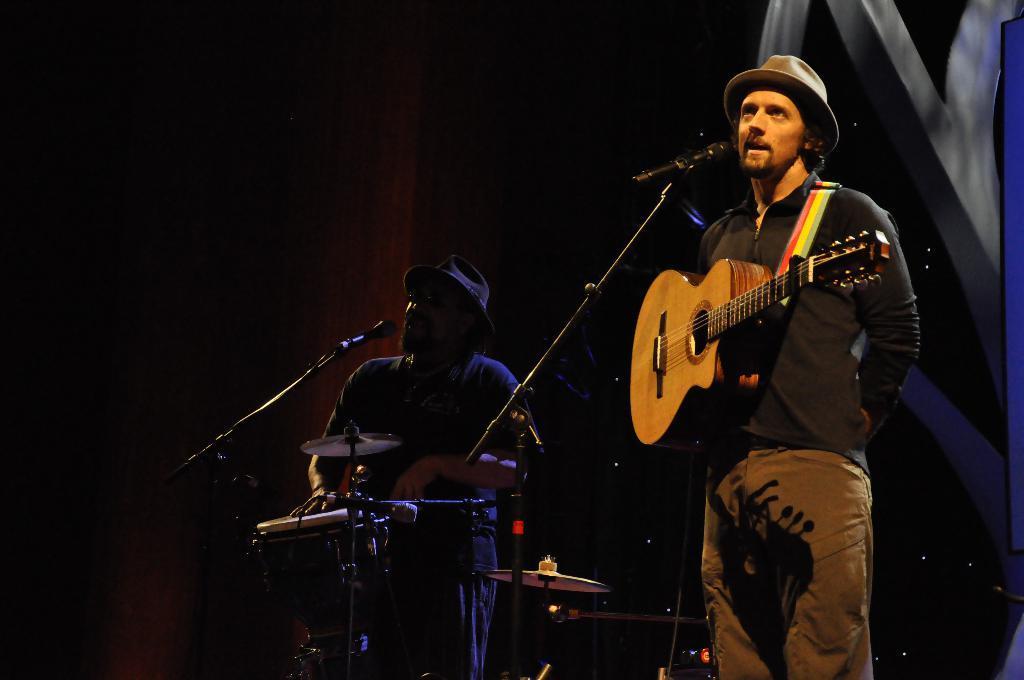Can you describe this image briefly? In this image there is a person standing at the right and holding guitar, there is a other person standing in the middle and playing drums. At the front there are microphones. 